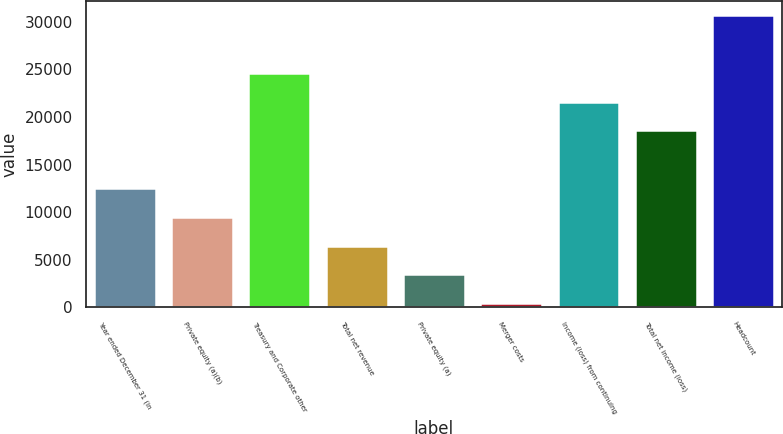<chart> <loc_0><loc_0><loc_500><loc_500><bar_chart><fcel>Year ended December 31 (in<fcel>Private equity (a)(b)<fcel>Treasury and Corporate other<fcel>Total net revenue<fcel>Private equity (a)<fcel>Merger costs<fcel>Income (loss) from continuing<fcel>Total net income (loss)<fcel>Headcount<nl><fcel>12535.2<fcel>9513.4<fcel>24622.4<fcel>6491.6<fcel>3469.8<fcel>448<fcel>21600.6<fcel>18578.8<fcel>30666<nl></chart> 